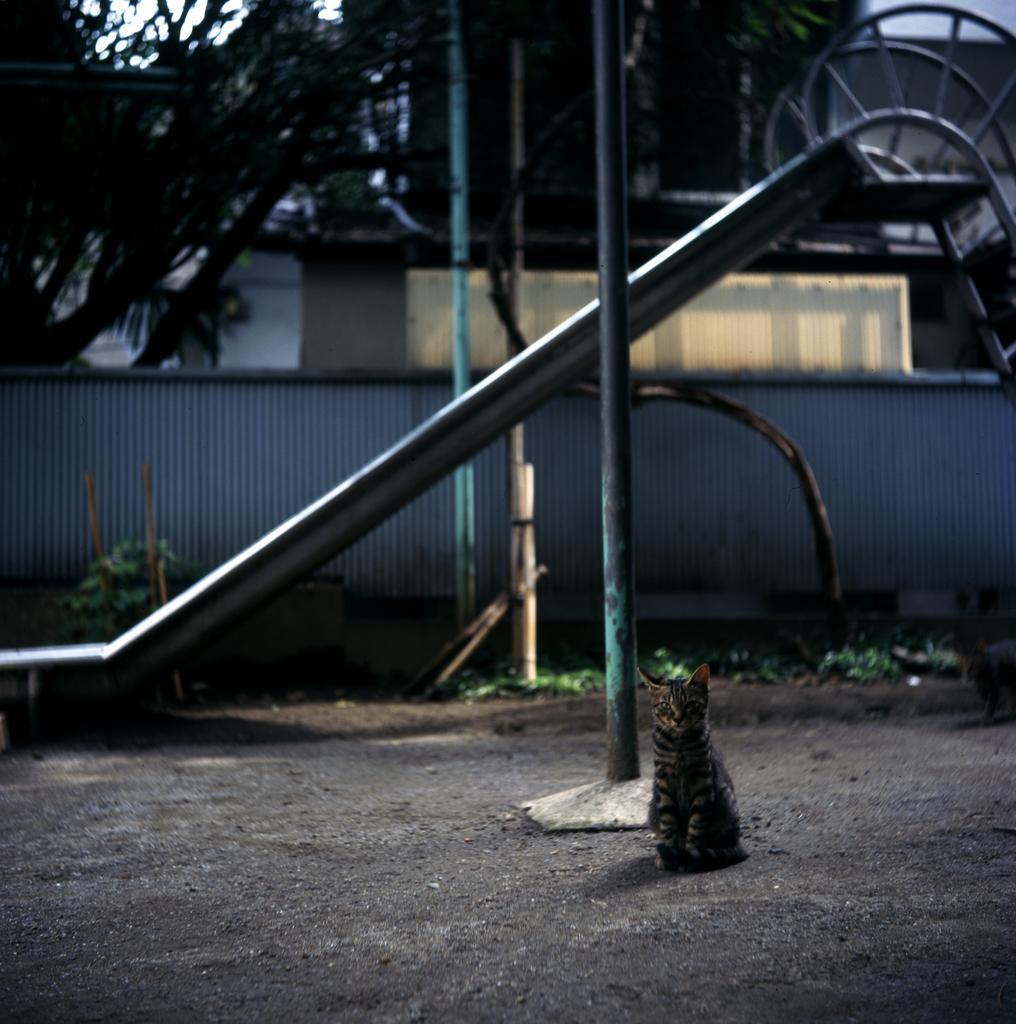Please provide a concise description of this image. In this picture we can see a slide, wall, plants and a cat on the ground and in the background we can see trees. 